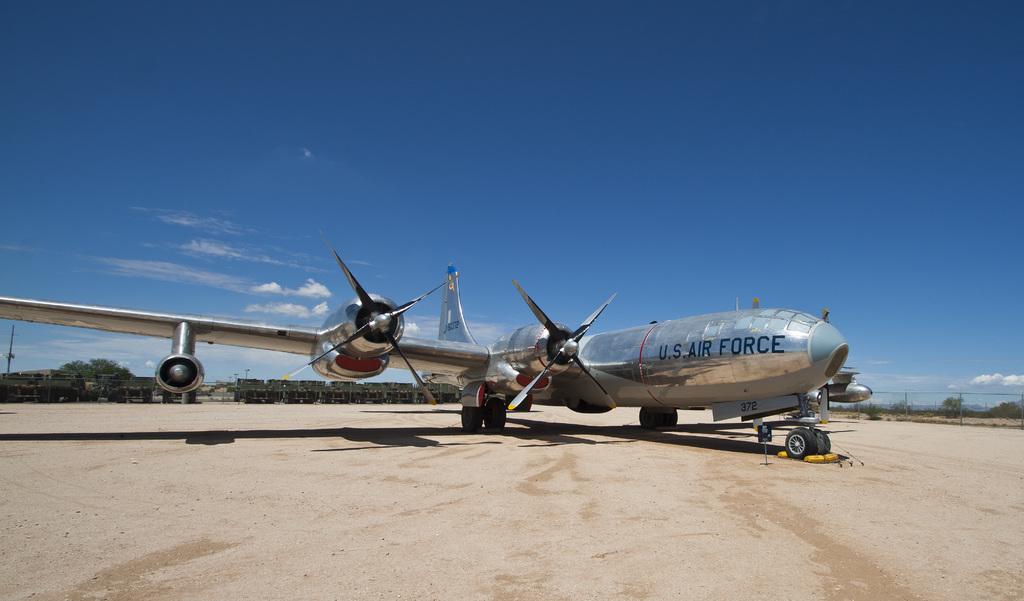What branch of the armed forces is this plane from?
Provide a short and direct response. Air force. Where is the plane from?
Ensure brevity in your answer.  U.s. 